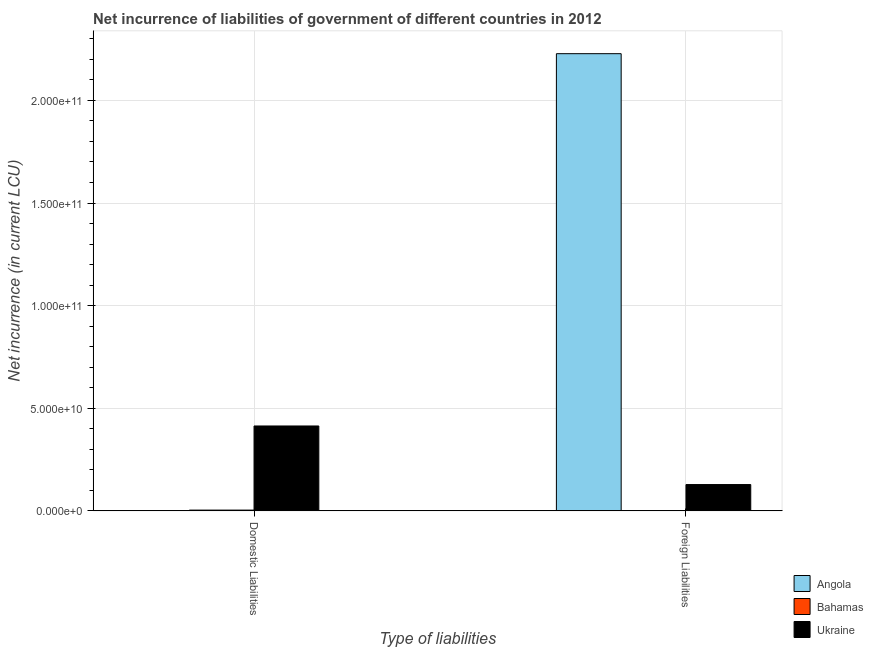How many different coloured bars are there?
Keep it short and to the point. 3. How many groups of bars are there?
Offer a very short reply. 2. Are the number of bars per tick equal to the number of legend labels?
Give a very brief answer. No. Are the number of bars on each tick of the X-axis equal?
Provide a short and direct response. No. How many bars are there on the 2nd tick from the left?
Keep it short and to the point. 3. How many bars are there on the 1st tick from the right?
Offer a very short reply. 3. What is the label of the 2nd group of bars from the left?
Your answer should be compact. Foreign Liabilities. What is the net incurrence of domestic liabilities in Ukraine?
Provide a short and direct response. 4.14e+1. Across all countries, what is the maximum net incurrence of domestic liabilities?
Make the answer very short. 4.14e+1. Across all countries, what is the minimum net incurrence of foreign liabilities?
Your answer should be compact. 7.28e+07. In which country was the net incurrence of foreign liabilities maximum?
Make the answer very short. Angola. What is the total net incurrence of foreign liabilities in the graph?
Your response must be concise. 2.36e+11. What is the difference between the net incurrence of foreign liabilities in Angola and that in Bahamas?
Offer a terse response. 2.23e+11. What is the difference between the net incurrence of domestic liabilities in Bahamas and the net incurrence of foreign liabilities in Angola?
Ensure brevity in your answer.  -2.22e+11. What is the average net incurrence of domestic liabilities per country?
Offer a terse response. 1.39e+1. What is the difference between the net incurrence of foreign liabilities and net incurrence of domestic liabilities in Bahamas?
Make the answer very short. -3.12e+08. What is the ratio of the net incurrence of foreign liabilities in Ukraine to that in Bahamas?
Offer a very short reply. 176.27. In how many countries, is the net incurrence of foreign liabilities greater than the average net incurrence of foreign liabilities taken over all countries?
Your answer should be very brief. 1. How many bars are there?
Your answer should be compact. 5. What is the difference between two consecutive major ticks on the Y-axis?
Offer a very short reply. 5.00e+1. Are the values on the major ticks of Y-axis written in scientific E-notation?
Offer a terse response. Yes. Does the graph contain grids?
Your response must be concise. Yes. How are the legend labels stacked?
Your answer should be very brief. Vertical. What is the title of the graph?
Offer a terse response. Net incurrence of liabilities of government of different countries in 2012. Does "Bosnia and Herzegovina" appear as one of the legend labels in the graph?
Your answer should be very brief. No. What is the label or title of the X-axis?
Your answer should be compact. Type of liabilities. What is the label or title of the Y-axis?
Your answer should be compact. Net incurrence (in current LCU). What is the Net incurrence (in current LCU) of Bahamas in Domestic Liabilities?
Offer a very short reply. 3.85e+08. What is the Net incurrence (in current LCU) in Ukraine in Domestic Liabilities?
Provide a succinct answer. 4.14e+1. What is the Net incurrence (in current LCU) in Angola in Foreign Liabilities?
Make the answer very short. 2.23e+11. What is the Net incurrence (in current LCU) in Bahamas in Foreign Liabilities?
Keep it short and to the point. 7.28e+07. What is the Net incurrence (in current LCU) of Ukraine in Foreign Liabilities?
Make the answer very short. 1.28e+1. Across all Type of liabilities, what is the maximum Net incurrence (in current LCU) of Angola?
Give a very brief answer. 2.23e+11. Across all Type of liabilities, what is the maximum Net incurrence (in current LCU) of Bahamas?
Make the answer very short. 3.85e+08. Across all Type of liabilities, what is the maximum Net incurrence (in current LCU) in Ukraine?
Give a very brief answer. 4.14e+1. Across all Type of liabilities, what is the minimum Net incurrence (in current LCU) of Angola?
Keep it short and to the point. 0. Across all Type of liabilities, what is the minimum Net incurrence (in current LCU) of Bahamas?
Offer a very short reply. 7.28e+07. Across all Type of liabilities, what is the minimum Net incurrence (in current LCU) in Ukraine?
Your answer should be compact. 1.28e+1. What is the total Net incurrence (in current LCU) of Angola in the graph?
Your answer should be compact. 2.23e+11. What is the total Net incurrence (in current LCU) in Bahamas in the graph?
Your answer should be very brief. 4.57e+08. What is the total Net incurrence (in current LCU) in Ukraine in the graph?
Provide a short and direct response. 5.42e+1. What is the difference between the Net incurrence (in current LCU) of Bahamas in Domestic Liabilities and that in Foreign Liabilities?
Keep it short and to the point. 3.12e+08. What is the difference between the Net incurrence (in current LCU) of Ukraine in Domestic Liabilities and that in Foreign Liabilities?
Ensure brevity in your answer.  2.85e+1. What is the difference between the Net incurrence (in current LCU) in Bahamas in Domestic Liabilities and the Net incurrence (in current LCU) in Ukraine in Foreign Liabilities?
Your answer should be compact. -1.24e+1. What is the average Net incurrence (in current LCU) in Angola per Type of liabilities?
Offer a very short reply. 1.11e+11. What is the average Net incurrence (in current LCU) of Bahamas per Type of liabilities?
Keep it short and to the point. 2.29e+08. What is the average Net incurrence (in current LCU) of Ukraine per Type of liabilities?
Your answer should be very brief. 2.71e+1. What is the difference between the Net incurrence (in current LCU) of Bahamas and Net incurrence (in current LCU) of Ukraine in Domestic Liabilities?
Your response must be concise. -4.10e+1. What is the difference between the Net incurrence (in current LCU) of Angola and Net incurrence (in current LCU) of Bahamas in Foreign Liabilities?
Your response must be concise. 2.23e+11. What is the difference between the Net incurrence (in current LCU) of Angola and Net incurrence (in current LCU) of Ukraine in Foreign Liabilities?
Make the answer very short. 2.10e+11. What is the difference between the Net incurrence (in current LCU) in Bahamas and Net incurrence (in current LCU) in Ukraine in Foreign Liabilities?
Make the answer very short. -1.28e+1. What is the ratio of the Net incurrence (in current LCU) in Bahamas in Domestic Liabilities to that in Foreign Liabilities?
Keep it short and to the point. 5.28. What is the ratio of the Net incurrence (in current LCU) in Ukraine in Domestic Liabilities to that in Foreign Liabilities?
Offer a very short reply. 3.22. What is the difference between the highest and the second highest Net incurrence (in current LCU) of Bahamas?
Keep it short and to the point. 3.12e+08. What is the difference between the highest and the second highest Net incurrence (in current LCU) in Ukraine?
Provide a succinct answer. 2.85e+1. What is the difference between the highest and the lowest Net incurrence (in current LCU) in Angola?
Offer a very short reply. 2.23e+11. What is the difference between the highest and the lowest Net incurrence (in current LCU) of Bahamas?
Give a very brief answer. 3.12e+08. What is the difference between the highest and the lowest Net incurrence (in current LCU) of Ukraine?
Your answer should be very brief. 2.85e+1. 